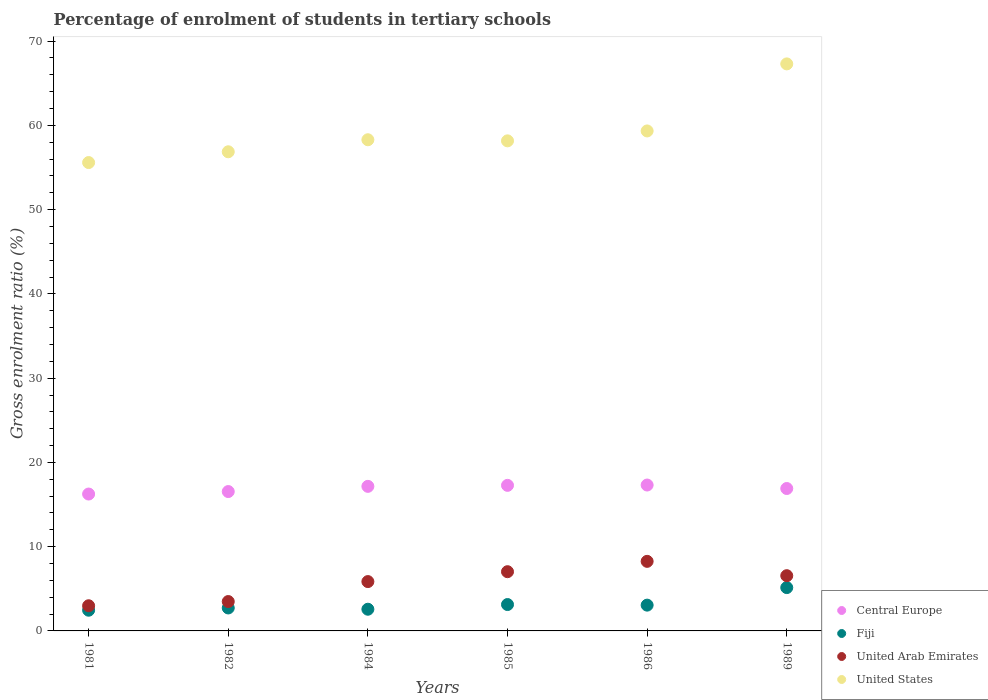How many different coloured dotlines are there?
Your answer should be compact. 4. Is the number of dotlines equal to the number of legend labels?
Make the answer very short. Yes. What is the percentage of students enrolled in tertiary schools in United Arab Emirates in 1981?
Provide a succinct answer. 2.99. Across all years, what is the maximum percentage of students enrolled in tertiary schools in Fiji?
Provide a short and direct response. 5.14. Across all years, what is the minimum percentage of students enrolled in tertiary schools in Fiji?
Provide a succinct answer. 2.46. What is the total percentage of students enrolled in tertiary schools in United States in the graph?
Make the answer very short. 355.55. What is the difference between the percentage of students enrolled in tertiary schools in Central Europe in 1981 and that in 1986?
Give a very brief answer. -1.07. What is the difference between the percentage of students enrolled in tertiary schools in United States in 1989 and the percentage of students enrolled in tertiary schools in Central Europe in 1981?
Give a very brief answer. 51.05. What is the average percentage of students enrolled in tertiary schools in Central Europe per year?
Your response must be concise. 16.91. In the year 1982, what is the difference between the percentage of students enrolled in tertiary schools in United States and percentage of students enrolled in tertiary schools in United Arab Emirates?
Offer a terse response. 53.38. What is the ratio of the percentage of students enrolled in tertiary schools in United Arab Emirates in 1981 to that in 1984?
Keep it short and to the point. 0.51. Is the percentage of students enrolled in tertiary schools in Central Europe in 1984 less than that in 1989?
Your response must be concise. No. What is the difference between the highest and the second highest percentage of students enrolled in tertiary schools in United States?
Ensure brevity in your answer.  7.96. What is the difference between the highest and the lowest percentage of students enrolled in tertiary schools in Fiji?
Give a very brief answer. 2.68. In how many years, is the percentage of students enrolled in tertiary schools in United States greater than the average percentage of students enrolled in tertiary schools in United States taken over all years?
Your answer should be compact. 2. Does the percentage of students enrolled in tertiary schools in United Arab Emirates monotonically increase over the years?
Ensure brevity in your answer.  No. Is the percentage of students enrolled in tertiary schools in Central Europe strictly greater than the percentage of students enrolled in tertiary schools in United Arab Emirates over the years?
Your answer should be very brief. Yes. How many dotlines are there?
Offer a very short reply. 4. How many years are there in the graph?
Make the answer very short. 6. Are the values on the major ticks of Y-axis written in scientific E-notation?
Make the answer very short. No. Does the graph contain grids?
Provide a succinct answer. No. Where does the legend appear in the graph?
Provide a succinct answer. Bottom right. What is the title of the graph?
Your answer should be compact. Percentage of enrolment of students in tertiary schools. What is the label or title of the Y-axis?
Your answer should be very brief. Gross enrolment ratio (%). What is the Gross enrolment ratio (%) of Central Europe in 1981?
Make the answer very short. 16.25. What is the Gross enrolment ratio (%) in Fiji in 1981?
Your answer should be very brief. 2.46. What is the Gross enrolment ratio (%) in United Arab Emirates in 1981?
Offer a terse response. 2.99. What is the Gross enrolment ratio (%) of United States in 1981?
Your answer should be compact. 55.59. What is the Gross enrolment ratio (%) of Central Europe in 1982?
Your answer should be very brief. 16.54. What is the Gross enrolment ratio (%) of Fiji in 1982?
Ensure brevity in your answer.  2.72. What is the Gross enrolment ratio (%) in United Arab Emirates in 1982?
Give a very brief answer. 3.49. What is the Gross enrolment ratio (%) in United States in 1982?
Ensure brevity in your answer.  56.87. What is the Gross enrolment ratio (%) in Central Europe in 1984?
Your response must be concise. 17.16. What is the Gross enrolment ratio (%) of Fiji in 1984?
Keep it short and to the point. 2.57. What is the Gross enrolment ratio (%) of United Arab Emirates in 1984?
Provide a succinct answer. 5.86. What is the Gross enrolment ratio (%) in United States in 1984?
Provide a succinct answer. 58.29. What is the Gross enrolment ratio (%) in Central Europe in 1985?
Provide a succinct answer. 17.28. What is the Gross enrolment ratio (%) in Fiji in 1985?
Your response must be concise. 3.13. What is the Gross enrolment ratio (%) of United Arab Emirates in 1985?
Your answer should be compact. 7.03. What is the Gross enrolment ratio (%) in United States in 1985?
Make the answer very short. 58.16. What is the Gross enrolment ratio (%) of Central Europe in 1986?
Your answer should be very brief. 17.32. What is the Gross enrolment ratio (%) of Fiji in 1986?
Your answer should be very brief. 3.06. What is the Gross enrolment ratio (%) in United Arab Emirates in 1986?
Your answer should be very brief. 8.26. What is the Gross enrolment ratio (%) in United States in 1986?
Your answer should be compact. 59.34. What is the Gross enrolment ratio (%) of Central Europe in 1989?
Offer a very short reply. 16.9. What is the Gross enrolment ratio (%) of Fiji in 1989?
Offer a terse response. 5.14. What is the Gross enrolment ratio (%) of United Arab Emirates in 1989?
Your response must be concise. 6.56. What is the Gross enrolment ratio (%) of United States in 1989?
Provide a short and direct response. 67.3. Across all years, what is the maximum Gross enrolment ratio (%) in Central Europe?
Provide a succinct answer. 17.32. Across all years, what is the maximum Gross enrolment ratio (%) of Fiji?
Your response must be concise. 5.14. Across all years, what is the maximum Gross enrolment ratio (%) in United Arab Emirates?
Give a very brief answer. 8.26. Across all years, what is the maximum Gross enrolment ratio (%) of United States?
Give a very brief answer. 67.3. Across all years, what is the minimum Gross enrolment ratio (%) of Central Europe?
Provide a succinct answer. 16.25. Across all years, what is the minimum Gross enrolment ratio (%) in Fiji?
Offer a terse response. 2.46. Across all years, what is the minimum Gross enrolment ratio (%) of United Arab Emirates?
Ensure brevity in your answer.  2.99. Across all years, what is the minimum Gross enrolment ratio (%) in United States?
Offer a terse response. 55.59. What is the total Gross enrolment ratio (%) in Central Europe in the graph?
Your response must be concise. 101.44. What is the total Gross enrolment ratio (%) in Fiji in the graph?
Offer a very short reply. 19.09. What is the total Gross enrolment ratio (%) of United Arab Emirates in the graph?
Your answer should be very brief. 34.17. What is the total Gross enrolment ratio (%) in United States in the graph?
Ensure brevity in your answer.  355.55. What is the difference between the Gross enrolment ratio (%) of Central Europe in 1981 and that in 1982?
Your answer should be compact. -0.3. What is the difference between the Gross enrolment ratio (%) of Fiji in 1981 and that in 1982?
Ensure brevity in your answer.  -0.27. What is the difference between the Gross enrolment ratio (%) of United Arab Emirates in 1981 and that in 1982?
Ensure brevity in your answer.  -0.5. What is the difference between the Gross enrolment ratio (%) of United States in 1981 and that in 1982?
Ensure brevity in your answer.  -1.28. What is the difference between the Gross enrolment ratio (%) of Central Europe in 1981 and that in 1984?
Provide a short and direct response. -0.91. What is the difference between the Gross enrolment ratio (%) in Fiji in 1981 and that in 1984?
Your answer should be compact. -0.12. What is the difference between the Gross enrolment ratio (%) in United Arab Emirates in 1981 and that in 1984?
Your response must be concise. -2.87. What is the difference between the Gross enrolment ratio (%) in United States in 1981 and that in 1984?
Offer a very short reply. -2.71. What is the difference between the Gross enrolment ratio (%) of Central Europe in 1981 and that in 1985?
Make the answer very short. -1.03. What is the difference between the Gross enrolment ratio (%) in Fiji in 1981 and that in 1985?
Your answer should be very brief. -0.67. What is the difference between the Gross enrolment ratio (%) in United Arab Emirates in 1981 and that in 1985?
Your answer should be very brief. -4.04. What is the difference between the Gross enrolment ratio (%) of United States in 1981 and that in 1985?
Give a very brief answer. -2.58. What is the difference between the Gross enrolment ratio (%) in Central Europe in 1981 and that in 1986?
Your answer should be very brief. -1.07. What is the difference between the Gross enrolment ratio (%) of Fiji in 1981 and that in 1986?
Provide a succinct answer. -0.6. What is the difference between the Gross enrolment ratio (%) of United Arab Emirates in 1981 and that in 1986?
Your answer should be compact. -5.27. What is the difference between the Gross enrolment ratio (%) in United States in 1981 and that in 1986?
Offer a very short reply. -3.75. What is the difference between the Gross enrolment ratio (%) in Central Europe in 1981 and that in 1989?
Offer a terse response. -0.66. What is the difference between the Gross enrolment ratio (%) of Fiji in 1981 and that in 1989?
Keep it short and to the point. -2.68. What is the difference between the Gross enrolment ratio (%) in United Arab Emirates in 1981 and that in 1989?
Make the answer very short. -3.57. What is the difference between the Gross enrolment ratio (%) of United States in 1981 and that in 1989?
Provide a succinct answer. -11.71. What is the difference between the Gross enrolment ratio (%) in Central Europe in 1982 and that in 1984?
Your answer should be very brief. -0.62. What is the difference between the Gross enrolment ratio (%) of Fiji in 1982 and that in 1984?
Give a very brief answer. 0.15. What is the difference between the Gross enrolment ratio (%) of United Arab Emirates in 1982 and that in 1984?
Provide a short and direct response. -2.37. What is the difference between the Gross enrolment ratio (%) of United States in 1982 and that in 1984?
Offer a very short reply. -1.43. What is the difference between the Gross enrolment ratio (%) of Central Europe in 1982 and that in 1985?
Provide a short and direct response. -0.74. What is the difference between the Gross enrolment ratio (%) in Fiji in 1982 and that in 1985?
Keep it short and to the point. -0.41. What is the difference between the Gross enrolment ratio (%) of United Arab Emirates in 1982 and that in 1985?
Make the answer very short. -3.54. What is the difference between the Gross enrolment ratio (%) of United States in 1982 and that in 1985?
Make the answer very short. -1.3. What is the difference between the Gross enrolment ratio (%) in Central Europe in 1982 and that in 1986?
Provide a short and direct response. -0.77. What is the difference between the Gross enrolment ratio (%) in Fiji in 1982 and that in 1986?
Give a very brief answer. -0.34. What is the difference between the Gross enrolment ratio (%) of United Arab Emirates in 1982 and that in 1986?
Provide a succinct answer. -4.77. What is the difference between the Gross enrolment ratio (%) of United States in 1982 and that in 1986?
Provide a succinct answer. -2.47. What is the difference between the Gross enrolment ratio (%) of Central Europe in 1982 and that in 1989?
Ensure brevity in your answer.  -0.36. What is the difference between the Gross enrolment ratio (%) of Fiji in 1982 and that in 1989?
Your answer should be very brief. -2.42. What is the difference between the Gross enrolment ratio (%) of United Arab Emirates in 1982 and that in 1989?
Your response must be concise. -3.07. What is the difference between the Gross enrolment ratio (%) of United States in 1982 and that in 1989?
Your response must be concise. -10.43. What is the difference between the Gross enrolment ratio (%) of Central Europe in 1984 and that in 1985?
Your answer should be compact. -0.12. What is the difference between the Gross enrolment ratio (%) of Fiji in 1984 and that in 1985?
Offer a terse response. -0.56. What is the difference between the Gross enrolment ratio (%) in United Arab Emirates in 1984 and that in 1985?
Provide a succinct answer. -1.17. What is the difference between the Gross enrolment ratio (%) in United States in 1984 and that in 1985?
Your answer should be very brief. 0.13. What is the difference between the Gross enrolment ratio (%) in Central Europe in 1984 and that in 1986?
Offer a very short reply. -0.16. What is the difference between the Gross enrolment ratio (%) in Fiji in 1984 and that in 1986?
Make the answer very short. -0.49. What is the difference between the Gross enrolment ratio (%) in United Arab Emirates in 1984 and that in 1986?
Offer a very short reply. -2.4. What is the difference between the Gross enrolment ratio (%) of United States in 1984 and that in 1986?
Give a very brief answer. -1.05. What is the difference between the Gross enrolment ratio (%) in Central Europe in 1984 and that in 1989?
Offer a very short reply. 0.26. What is the difference between the Gross enrolment ratio (%) in Fiji in 1984 and that in 1989?
Provide a short and direct response. -2.57. What is the difference between the Gross enrolment ratio (%) of United Arab Emirates in 1984 and that in 1989?
Keep it short and to the point. -0.7. What is the difference between the Gross enrolment ratio (%) in United States in 1984 and that in 1989?
Provide a succinct answer. -9. What is the difference between the Gross enrolment ratio (%) of Central Europe in 1985 and that in 1986?
Make the answer very short. -0.04. What is the difference between the Gross enrolment ratio (%) in Fiji in 1985 and that in 1986?
Your answer should be compact. 0.07. What is the difference between the Gross enrolment ratio (%) in United Arab Emirates in 1985 and that in 1986?
Provide a succinct answer. -1.23. What is the difference between the Gross enrolment ratio (%) of United States in 1985 and that in 1986?
Offer a terse response. -1.18. What is the difference between the Gross enrolment ratio (%) in Central Europe in 1985 and that in 1989?
Your answer should be compact. 0.38. What is the difference between the Gross enrolment ratio (%) of Fiji in 1985 and that in 1989?
Ensure brevity in your answer.  -2.01. What is the difference between the Gross enrolment ratio (%) of United Arab Emirates in 1985 and that in 1989?
Offer a very short reply. 0.47. What is the difference between the Gross enrolment ratio (%) in United States in 1985 and that in 1989?
Offer a terse response. -9.13. What is the difference between the Gross enrolment ratio (%) of Central Europe in 1986 and that in 1989?
Provide a short and direct response. 0.41. What is the difference between the Gross enrolment ratio (%) of Fiji in 1986 and that in 1989?
Make the answer very short. -2.08. What is the difference between the Gross enrolment ratio (%) in United Arab Emirates in 1986 and that in 1989?
Offer a very short reply. 1.7. What is the difference between the Gross enrolment ratio (%) of United States in 1986 and that in 1989?
Offer a very short reply. -7.96. What is the difference between the Gross enrolment ratio (%) in Central Europe in 1981 and the Gross enrolment ratio (%) in Fiji in 1982?
Ensure brevity in your answer.  13.52. What is the difference between the Gross enrolment ratio (%) in Central Europe in 1981 and the Gross enrolment ratio (%) in United Arab Emirates in 1982?
Provide a succinct answer. 12.76. What is the difference between the Gross enrolment ratio (%) of Central Europe in 1981 and the Gross enrolment ratio (%) of United States in 1982?
Offer a very short reply. -40.62. What is the difference between the Gross enrolment ratio (%) of Fiji in 1981 and the Gross enrolment ratio (%) of United Arab Emirates in 1982?
Give a very brief answer. -1.03. What is the difference between the Gross enrolment ratio (%) in Fiji in 1981 and the Gross enrolment ratio (%) in United States in 1982?
Offer a terse response. -54.41. What is the difference between the Gross enrolment ratio (%) in United Arab Emirates in 1981 and the Gross enrolment ratio (%) in United States in 1982?
Provide a succinct answer. -53.88. What is the difference between the Gross enrolment ratio (%) in Central Europe in 1981 and the Gross enrolment ratio (%) in Fiji in 1984?
Provide a short and direct response. 13.67. What is the difference between the Gross enrolment ratio (%) of Central Europe in 1981 and the Gross enrolment ratio (%) of United Arab Emirates in 1984?
Your answer should be very brief. 10.39. What is the difference between the Gross enrolment ratio (%) of Central Europe in 1981 and the Gross enrolment ratio (%) of United States in 1984?
Keep it short and to the point. -42.05. What is the difference between the Gross enrolment ratio (%) in Fiji in 1981 and the Gross enrolment ratio (%) in United Arab Emirates in 1984?
Provide a short and direct response. -3.4. What is the difference between the Gross enrolment ratio (%) in Fiji in 1981 and the Gross enrolment ratio (%) in United States in 1984?
Your response must be concise. -55.84. What is the difference between the Gross enrolment ratio (%) in United Arab Emirates in 1981 and the Gross enrolment ratio (%) in United States in 1984?
Offer a very short reply. -55.31. What is the difference between the Gross enrolment ratio (%) in Central Europe in 1981 and the Gross enrolment ratio (%) in Fiji in 1985?
Offer a very short reply. 13.11. What is the difference between the Gross enrolment ratio (%) of Central Europe in 1981 and the Gross enrolment ratio (%) of United Arab Emirates in 1985?
Offer a terse response. 9.22. What is the difference between the Gross enrolment ratio (%) of Central Europe in 1981 and the Gross enrolment ratio (%) of United States in 1985?
Your answer should be compact. -41.92. What is the difference between the Gross enrolment ratio (%) of Fiji in 1981 and the Gross enrolment ratio (%) of United Arab Emirates in 1985?
Keep it short and to the point. -4.57. What is the difference between the Gross enrolment ratio (%) of Fiji in 1981 and the Gross enrolment ratio (%) of United States in 1985?
Ensure brevity in your answer.  -55.71. What is the difference between the Gross enrolment ratio (%) of United Arab Emirates in 1981 and the Gross enrolment ratio (%) of United States in 1985?
Offer a terse response. -55.18. What is the difference between the Gross enrolment ratio (%) of Central Europe in 1981 and the Gross enrolment ratio (%) of Fiji in 1986?
Your answer should be very brief. 13.19. What is the difference between the Gross enrolment ratio (%) in Central Europe in 1981 and the Gross enrolment ratio (%) in United Arab Emirates in 1986?
Ensure brevity in your answer.  7.99. What is the difference between the Gross enrolment ratio (%) of Central Europe in 1981 and the Gross enrolment ratio (%) of United States in 1986?
Give a very brief answer. -43.09. What is the difference between the Gross enrolment ratio (%) in Fiji in 1981 and the Gross enrolment ratio (%) in United Arab Emirates in 1986?
Offer a very short reply. -5.8. What is the difference between the Gross enrolment ratio (%) of Fiji in 1981 and the Gross enrolment ratio (%) of United States in 1986?
Give a very brief answer. -56.88. What is the difference between the Gross enrolment ratio (%) in United Arab Emirates in 1981 and the Gross enrolment ratio (%) in United States in 1986?
Ensure brevity in your answer.  -56.35. What is the difference between the Gross enrolment ratio (%) in Central Europe in 1981 and the Gross enrolment ratio (%) in Fiji in 1989?
Ensure brevity in your answer.  11.1. What is the difference between the Gross enrolment ratio (%) of Central Europe in 1981 and the Gross enrolment ratio (%) of United Arab Emirates in 1989?
Make the answer very short. 9.69. What is the difference between the Gross enrolment ratio (%) of Central Europe in 1981 and the Gross enrolment ratio (%) of United States in 1989?
Provide a succinct answer. -51.05. What is the difference between the Gross enrolment ratio (%) in Fiji in 1981 and the Gross enrolment ratio (%) in United Arab Emirates in 1989?
Your answer should be compact. -4.1. What is the difference between the Gross enrolment ratio (%) in Fiji in 1981 and the Gross enrolment ratio (%) in United States in 1989?
Keep it short and to the point. -64.84. What is the difference between the Gross enrolment ratio (%) in United Arab Emirates in 1981 and the Gross enrolment ratio (%) in United States in 1989?
Ensure brevity in your answer.  -64.31. What is the difference between the Gross enrolment ratio (%) of Central Europe in 1982 and the Gross enrolment ratio (%) of Fiji in 1984?
Make the answer very short. 13.97. What is the difference between the Gross enrolment ratio (%) in Central Europe in 1982 and the Gross enrolment ratio (%) in United Arab Emirates in 1984?
Give a very brief answer. 10.69. What is the difference between the Gross enrolment ratio (%) in Central Europe in 1982 and the Gross enrolment ratio (%) in United States in 1984?
Make the answer very short. -41.75. What is the difference between the Gross enrolment ratio (%) in Fiji in 1982 and the Gross enrolment ratio (%) in United Arab Emirates in 1984?
Provide a succinct answer. -3.13. What is the difference between the Gross enrolment ratio (%) of Fiji in 1982 and the Gross enrolment ratio (%) of United States in 1984?
Your answer should be compact. -55.57. What is the difference between the Gross enrolment ratio (%) of United Arab Emirates in 1982 and the Gross enrolment ratio (%) of United States in 1984?
Provide a succinct answer. -54.81. What is the difference between the Gross enrolment ratio (%) in Central Europe in 1982 and the Gross enrolment ratio (%) in Fiji in 1985?
Your response must be concise. 13.41. What is the difference between the Gross enrolment ratio (%) of Central Europe in 1982 and the Gross enrolment ratio (%) of United Arab Emirates in 1985?
Keep it short and to the point. 9.51. What is the difference between the Gross enrolment ratio (%) of Central Europe in 1982 and the Gross enrolment ratio (%) of United States in 1985?
Give a very brief answer. -41.62. What is the difference between the Gross enrolment ratio (%) in Fiji in 1982 and the Gross enrolment ratio (%) in United Arab Emirates in 1985?
Ensure brevity in your answer.  -4.3. What is the difference between the Gross enrolment ratio (%) in Fiji in 1982 and the Gross enrolment ratio (%) in United States in 1985?
Keep it short and to the point. -55.44. What is the difference between the Gross enrolment ratio (%) in United Arab Emirates in 1982 and the Gross enrolment ratio (%) in United States in 1985?
Ensure brevity in your answer.  -54.68. What is the difference between the Gross enrolment ratio (%) of Central Europe in 1982 and the Gross enrolment ratio (%) of Fiji in 1986?
Offer a terse response. 13.48. What is the difference between the Gross enrolment ratio (%) in Central Europe in 1982 and the Gross enrolment ratio (%) in United Arab Emirates in 1986?
Provide a short and direct response. 8.28. What is the difference between the Gross enrolment ratio (%) in Central Europe in 1982 and the Gross enrolment ratio (%) in United States in 1986?
Provide a short and direct response. -42.8. What is the difference between the Gross enrolment ratio (%) in Fiji in 1982 and the Gross enrolment ratio (%) in United Arab Emirates in 1986?
Make the answer very short. -5.53. What is the difference between the Gross enrolment ratio (%) of Fiji in 1982 and the Gross enrolment ratio (%) of United States in 1986?
Give a very brief answer. -56.62. What is the difference between the Gross enrolment ratio (%) of United Arab Emirates in 1982 and the Gross enrolment ratio (%) of United States in 1986?
Provide a succinct answer. -55.85. What is the difference between the Gross enrolment ratio (%) of Central Europe in 1982 and the Gross enrolment ratio (%) of Fiji in 1989?
Provide a succinct answer. 11.4. What is the difference between the Gross enrolment ratio (%) of Central Europe in 1982 and the Gross enrolment ratio (%) of United Arab Emirates in 1989?
Provide a short and direct response. 9.99. What is the difference between the Gross enrolment ratio (%) in Central Europe in 1982 and the Gross enrolment ratio (%) in United States in 1989?
Give a very brief answer. -50.76. What is the difference between the Gross enrolment ratio (%) in Fiji in 1982 and the Gross enrolment ratio (%) in United Arab Emirates in 1989?
Ensure brevity in your answer.  -3.83. What is the difference between the Gross enrolment ratio (%) of Fiji in 1982 and the Gross enrolment ratio (%) of United States in 1989?
Ensure brevity in your answer.  -64.57. What is the difference between the Gross enrolment ratio (%) in United Arab Emirates in 1982 and the Gross enrolment ratio (%) in United States in 1989?
Your answer should be very brief. -63.81. What is the difference between the Gross enrolment ratio (%) of Central Europe in 1984 and the Gross enrolment ratio (%) of Fiji in 1985?
Your response must be concise. 14.03. What is the difference between the Gross enrolment ratio (%) of Central Europe in 1984 and the Gross enrolment ratio (%) of United Arab Emirates in 1985?
Your answer should be very brief. 10.13. What is the difference between the Gross enrolment ratio (%) in Central Europe in 1984 and the Gross enrolment ratio (%) in United States in 1985?
Offer a very short reply. -41.01. What is the difference between the Gross enrolment ratio (%) of Fiji in 1984 and the Gross enrolment ratio (%) of United Arab Emirates in 1985?
Offer a terse response. -4.46. What is the difference between the Gross enrolment ratio (%) of Fiji in 1984 and the Gross enrolment ratio (%) of United States in 1985?
Offer a terse response. -55.59. What is the difference between the Gross enrolment ratio (%) of United Arab Emirates in 1984 and the Gross enrolment ratio (%) of United States in 1985?
Your response must be concise. -52.31. What is the difference between the Gross enrolment ratio (%) in Central Europe in 1984 and the Gross enrolment ratio (%) in Fiji in 1986?
Your answer should be compact. 14.1. What is the difference between the Gross enrolment ratio (%) of Central Europe in 1984 and the Gross enrolment ratio (%) of United Arab Emirates in 1986?
Provide a succinct answer. 8.9. What is the difference between the Gross enrolment ratio (%) in Central Europe in 1984 and the Gross enrolment ratio (%) in United States in 1986?
Provide a succinct answer. -42.18. What is the difference between the Gross enrolment ratio (%) in Fiji in 1984 and the Gross enrolment ratio (%) in United Arab Emirates in 1986?
Provide a short and direct response. -5.68. What is the difference between the Gross enrolment ratio (%) in Fiji in 1984 and the Gross enrolment ratio (%) in United States in 1986?
Your answer should be very brief. -56.77. What is the difference between the Gross enrolment ratio (%) of United Arab Emirates in 1984 and the Gross enrolment ratio (%) of United States in 1986?
Offer a terse response. -53.48. What is the difference between the Gross enrolment ratio (%) in Central Europe in 1984 and the Gross enrolment ratio (%) in Fiji in 1989?
Offer a terse response. 12.02. What is the difference between the Gross enrolment ratio (%) of Central Europe in 1984 and the Gross enrolment ratio (%) of United Arab Emirates in 1989?
Give a very brief answer. 10.6. What is the difference between the Gross enrolment ratio (%) of Central Europe in 1984 and the Gross enrolment ratio (%) of United States in 1989?
Keep it short and to the point. -50.14. What is the difference between the Gross enrolment ratio (%) in Fiji in 1984 and the Gross enrolment ratio (%) in United Arab Emirates in 1989?
Ensure brevity in your answer.  -3.98. What is the difference between the Gross enrolment ratio (%) of Fiji in 1984 and the Gross enrolment ratio (%) of United States in 1989?
Offer a very short reply. -64.72. What is the difference between the Gross enrolment ratio (%) of United Arab Emirates in 1984 and the Gross enrolment ratio (%) of United States in 1989?
Make the answer very short. -61.44. What is the difference between the Gross enrolment ratio (%) in Central Europe in 1985 and the Gross enrolment ratio (%) in Fiji in 1986?
Make the answer very short. 14.22. What is the difference between the Gross enrolment ratio (%) of Central Europe in 1985 and the Gross enrolment ratio (%) of United Arab Emirates in 1986?
Offer a terse response. 9.02. What is the difference between the Gross enrolment ratio (%) in Central Europe in 1985 and the Gross enrolment ratio (%) in United States in 1986?
Provide a succinct answer. -42.06. What is the difference between the Gross enrolment ratio (%) in Fiji in 1985 and the Gross enrolment ratio (%) in United Arab Emirates in 1986?
Make the answer very short. -5.13. What is the difference between the Gross enrolment ratio (%) of Fiji in 1985 and the Gross enrolment ratio (%) of United States in 1986?
Offer a very short reply. -56.21. What is the difference between the Gross enrolment ratio (%) of United Arab Emirates in 1985 and the Gross enrolment ratio (%) of United States in 1986?
Your response must be concise. -52.31. What is the difference between the Gross enrolment ratio (%) in Central Europe in 1985 and the Gross enrolment ratio (%) in Fiji in 1989?
Provide a short and direct response. 12.13. What is the difference between the Gross enrolment ratio (%) of Central Europe in 1985 and the Gross enrolment ratio (%) of United Arab Emirates in 1989?
Your response must be concise. 10.72. What is the difference between the Gross enrolment ratio (%) in Central Europe in 1985 and the Gross enrolment ratio (%) in United States in 1989?
Make the answer very short. -50.02. What is the difference between the Gross enrolment ratio (%) in Fiji in 1985 and the Gross enrolment ratio (%) in United Arab Emirates in 1989?
Your answer should be compact. -3.42. What is the difference between the Gross enrolment ratio (%) of Fiji in 1985 and the Gross enrolment ratio (%) of United States in 1989?
Offer a very short reply. -64.17. What is the difference between the Gross enrolment ratio (%) in United Arab Emirates in 1985 and the Gross enrolment ratio (%) in United States in 1989?
Ensure brevity in your answer.  -60.27. What is the difference between the Gross enrolment ratio (%) in Central Europe in 1986 and the Gross enrolment ratio (%) in Fiji in 1989?
Your answer should be compact. 12.17. What is the difference between the Gross enrolment ratio (%) in Central Europe in 1986 and the Gross enrolment ratio (%) in United Arab Emirates in 1989?
Your answer should be very brief. 10.76. What is the difference between the Gross enrolment ratio (%) in Central Europe in 1986 and the Gross enrolment ratio (%) in United States in 1989?
Offer a terse response. -49.98. What is the difference between the Gross enrolment ratio (%) in Fiji in 1986 and the Gross enrolment ratio (%) in United Arab Emirates in 1989?
Make the answer very short. -3.49. What is the difference between the Gross enrolment ratio (%) in Fiji in 1986 and the Gross enrolment ratio (%) in United States in 1989?
Provide a succinct answer. -64.24. What is the difference between the Gross enrolment ratio (%) in United Arab Emirates in 1986 and the Gross enrolment ratio (%) in United States in 1989?
Your response must be concise. -59.04. What is the average Gross enrolment ratio (%) in Central Europe per year?
Offer a very short reply. 16.91. What is the average Gross enrolment ratio (%) of Fiji per year?
Provide a short and direct response. 3.18. What is the average Gross enrolment ratio (%) in United Arab Emirates per year?
Make the answer very short. 5.7. What is the average Gross enrolment ratio (%) in United States per year?
Offer a very short reply. 59.26. In the year 1981, what is the difference between the Gross enrolment ratio (%) of Central Europe and Gross enrolment ratio (%) of Fiji?
Keep it short and to the point. 13.79. In the year 1981, what is the difference between the Gross enrolment ratio (%) in Central Europe and Gross enrolment ratio (%) in United Arab Emirates?
Offer a very short reply. 13.26. In the year 1981, what is the difference between the Gross enrolment ratio (%) of Central Europe and Gross enrolment ratio (%) of United States?
Offer a terse response. -39.34. In the year 1981, what is the difference between the Gross enrolment ratio (%) in Fiji and Gross enrolment ratio (%) in United Arab Emirates?
Give a very brief answer. -0.53. In the year 1981, what is the difference between the Gross enrolment ratio (%) of Fiji and Gross enrolment ratio (%) of United States?
Your answer should be compact. -53.13. In the year 1981, what is the difference between the Gross enrolment ratio (%) of United Arab Emirates and Gross enrolment ratio (%) of United States?
Provide a succinct answer. -52.6. In the year 1982, what is the difference between the Gross enrolment ratio (%) in Central Europe and Gross enrolment ratio (%) in Fiji?
Offer a terse response. 13.82. In the year 1982, what is the difference between the Gross enrolment ratio (%) of Central Europe and Gross enrolment ratio (%) of United Arab Emirates?
Make the answer very short. 13.06. In the year 1982, what is the difference between the Gross enrolment ratio (%) of Central Europe and Gross enrolment ratio (%) of United States?
Your response must be concise. -40.33. In the year 1982, what is the difference between the Gross enrolment ratio (%) in Fiji and Gross enrolment ratio (%) in United Arab Emirates?
Keep it short and to the point. -0.76. In the year 1982, what is the difference between the Gross enrolment ratio (%) of Fiji and Gross enrolment ratio (%) of United States?
Provide a short and direct response. -54.14. In the year 1982, what is the difference between the Gross enrolment ratio (%) of United Arab Emirates and Gross enrolment ratio (%) of United States?
Offer a terse response. -53.38. In the year 1984, what is the difference between the Gross enrolment ratio (%) in Central Europe and Gross enrolment ratio (%) in Fiji?
Provide a short and direct response. 14.58. In the year 1984, what is the difference between the Gross enrolment ratio (%) of Central Europe and Gross enrolment ratio (%) of United Arab Emirates?
Provide a short and direct response. 11.3. In the year 1984, what is the difference between the Gross enrolment ratio (%) of Central Europe and Gross enrolment ratio (%) of United States?
Your response must be concise. -41.14. In the year 1984, what is the difference between the Gross enrolment ratio (%) in Fiji and Gross enrolment ratio (%) in United Arab Emirates?
Offer a very short reply. -3.28. In the year 1984, what is the difference between the Gross enrolment ratio (%) of Fiji and Gross enrolment ratio (%) of United States?
Make the answer very short. -55.72. In the year 1984, what is the difference between the Gross enrolment ratio (%) in United Arab Emirates and Gross enrolment ratio (%) in United States?
Give a very brief answer. -52.44. In the year 1985, what is the difference between the Gross enrolment ratio (%) of Central Europe and Gross enrolment ratio (%) of Fiji?
Ensure brevity in your answer.  14.15. In the year 1985, what is the difference between the Gross enrolment ratio (%) in Central Europe and Gross enrolment ratio (%) in United Arab Emirates?
Ensure brevity in your answer.  10.25. In the year 1985, what is the difference between the Gross enrolment ratio (%) in Central Europe and Gross enrolment ratio (%) in United States?
Provide a short and direct response. -40.89. In the year 1985, what is the difference between the Gross enrolment ratio (%) in Fiji and Gross enrolment ratio (%) in United Arab Emirates?
Your answer should be compact. -3.9. In the year 1985, what is the difference between the Gross enrolment ratio (%) of Fiji and Gross enrolment ratio (%) of United States?
Make the answer very short. -55.03. In the year 1985, what is the difference between the Gross enrolment ratio (%) of United Arab Emirates and Gross enrolment ratio (%) of United States?
Your response must be concise. -51.14. In the year 1986, what is the difference between the Gross enrolment ratio (%) in Central Europe and Gross enrolment ratio (%) in Fiji?
Ensure brevity in your answer.  14.25. In the year 1986, what is the difference between the Gross enrolment ratio (%) of Central Europe and Gross enrolment ratio (%) of United Arab Emirates?
Your answer should be very brief. 9.06. In the year 1986, what is the difference between the Gross enrolment ratio (%) in Central Europe and Gross enrolment ratio (%) in United States?
Ensure brevity in your answer.  -42.02. In the year 1986, what is the difference between the Gross enrolment ratio (%) of Fiji and Gross enrolment ratio (%) of United Arab Emirates?
Offer a very short reply. -5.2. In the year 1986, what is the difference between the Gross enrolment ratio (%) of Fiji and Gross enrolment ratio (%) of United States?
Your answer should be very brief. -56.28. In the year 1986, what is the difference between the Gross enrolment ratio (%) in United Arab Emirates and Gross enrolment ratio (%) in United States?
Your response must be concise. -51.08. In the year 1989, what is the difference between the Gross enrolment ratio (%) in Central Europe and Gross enrolment ratio (%) in Fiji?
Provide a short and direct response. 11.76. In the year 1989, what is the difference between the Gross enrolment ratio (%) of Central Europe and Gross enrolment ratio (%) of United Arab Emirates?
Offer a terse response. 10.35. In the year 1989, what is the difference between the Gross enrolment ratio (%) in Central Europe and Gross enrolment ratio (%) in United States?
Offer a terse response. -50.4. In the year 1989, what is the difference between the Gross enrolment ratio (%) in Fiji and Gross enrolment ratio (%) in United Arab Emirates?
Ensure brevity in your answer.  -1.41. In the year 1989, what is the difference between the Gross enrolment ratio (%) in Fiji and Gross enrolment ratio (%) in United States?
Your response must be concise. -62.16. In the year 1989, what is the difference between the Gross enrolment ratio (%) of United Arab Emirates and Gross enrolment ratio (%) of United States?
Keep it short and to the point. -60.74. What is the ratio of the Gross enrolment ratio (%) of Central Europe in 1981 to that in 1982?
Give a very brief answer. 0.98. What is the ratio of the Gross enrolment ratio (%) of Fiji in 1981 to that in 1982?
Your answer should be compact. 0.9. What is the ratio of the Gross enrolment ratio (%) of United Arab Emirates in 1981 to that in 1982?
Provide a succinct answer. 0.86. What is the ratio of the Gross enrolment ratio (%) of United States in 1981 to that in 1982?
Provide a short and direct response. 0.98. What is the ratio of the Gross enrolment ratio (%) of Central Europe in 1981 to that in 1984?
Your answer should be compact. 0.95. What is the ratio of the Gross enrolment ratio (%) in Fiji in 1981 to that in 1984?
Provide a short and direct response. 0.96. What is the ratio of the Gross enrolment ratio (%) of United Arab Emirates in 1981 to that in 1984?
Provide a short and direct response. 0.51. What is the ratio of the Gross enrolment ratio (%) in United States in 1981 to that in 1984?
Provide a short and direct response. 0.95. What is the ratio of the Gross enrolment ratio (%) of Central Europe in 1981 to that in 1985?
Your answer should be compact. 0.94. What is the ratio of the Gross enrolment ratio (%) in Fiji in 1981 to that in 1985?
Provide a short and direct response. 0.79. What is the ratio of the Gross enrolment ratio (%) in United Arab Emirates in 1981 to that in 1985?
Provide a succinct answer. 0.42. What is the ratio of the Gross enrolment ratio (%) of United States in 1981 to that in 1985?
Your answer should be compact. 0.96. What is the ratio of the Gross enrolment ratio (%) in Central Europe in 1981 to that in 1986?
Provide a short and direct response. 0.94. What is the ratio of the Gross enrolment ratio (%) of Fiji in 1981 to that in 1986?
Give a very brief answer. 0.8. What is the ratio of the Gross enrolment ratio (%) of United Arab Emirates in 1981 to that in 1986?
Your response must be concise. 0.36. What is the ratio of the Gross enrolment ratio (%) in United States in 1981 to that in 1986?
Offer a terse response. 0.94. What is the ratio of the Gross enrolment ratio (%) of Central Europe in 1981 to that in 1989?
Offer a very short reply. 0.96. What is the ratio of the Gross enrolment ratio (%) of Fiji in 1981 to that in 1989?
Your answer should be compact. 0.48. What is the ratio of the Gross enrolment ratio (%) of United Arab Emirates in 1981 to that in 1989?
Make the answer very short. 0.46. What is the ratio of the Gross enrolment ratio (%) in United States in 1981 to that in 1989?
Offer a terse response. 0.83. What is the ratio of the Gross enrolment ratio (%) of Central Europe in 1982 to that in 1984?
Your answer should be compact. 0.96. What is the ratio of the Gross enrolment ratio (%) in Fiji in 1982 to that in 1984?
Offer a terse response. 1.06. What is the ratio of the Gross enrolment ratio (%) in United Arab Emirates in 1982 to that in 1984?
Your answer should be very brief. 0.6. What is the ratio of the Gross enrolment ratio (%) in United States in 1982 to that in 1984?
Keep it short and to the point. 0.98. What is the ratio of the Gross enrolment ratio (%) in Central Europe in 1982 to that in 1985?
Provide a short and direct response. 0.96. What is the ratio of the Gross enrolment ratio (%) in Fiji in 1982 to that in 1985?
Provide a short and direct response. 0.87. What is the ratio of the Gross enrolment ratio (%) in United Arab Emirates in 1982 to that in 1985?
Give a very brief answer. 0.5. What is the ratio of the Gross enrolment ratio (%) of United States in 1982 to that in 1985?
Keep it short and to the point. 0.98. What is the ratio of the Gross enrolment ratio (%) in Central Europe in 1982 to that in 1986?
Your answer should be very brief. 0.96. What is the ratio of the Gross enrolment ratio (%) in Fiji in 1982 to that in 1986?
Provide a short and direct response. 0.89. What is the ratio of the Gross enrolment ratio (%) in United Arab Emirates in 1982 to that in 1986?
Provide a short and direct response. 0.42. What is the ratio of the Gross enrolment ratio (%) of United States in 1982 to that in 1986?
Provide a short and direct response. 0.96. What is the ratio of the Gross enrolment ratio (%) of Central Europe in 1982 to that in 1989?
Your answer should be compact. 0.98. What is the ratio of the Gross enrolment ratio (%) of Fiji in 1982 to that in 1989?
Offer a very short reply. 0.53. What is the ratio of the Gross enrolment ratio (%) in United Arab Emirates in 1982 to that in 1989?
Offer a terse response. 0.53. What is the ratio of the Gross enrolment ratio (%) of United States in 1982 to that in 1989?
Offer a terse response. 0.84. What is the ratio of the Gross enrolment ratio (%) of Central Europe in 1984 to that in 1985?
Your response must be concise. 0.99. What is the ratio of the Gross enrolment ratio (%) in Fiji in 1984 to that in 1985?
Your response must be concise. 0.82. What is the ratio of the Gross enrolment ratio (%) of United Arab Emirates in 1984 to that in 1985?
Your answer should be very brief. 0.83. What is the ratio of the Gross enrolment ratio (%) in Central Europe in 1984 to that in 1986?
Give a very brief answer. 0.99. What is the ratio of the Gross enrolment ratio (%) in Fiji in 1984 to that in 1986?
Your response must be concise. 0.84. What is the ratio of the Gross enrolment ratio (%) of United Arab Emirates in 1984 to that in 1986?
Your answer should be compact. 0.71. What is the ratio of the Gross enrolment ratio (%) of United States in 1984 to that in 1986?
Provide a succinct answer. 0.98. What is the ratio of the Gross enrolment ratio (%) in Central Europe in 1984 to that in 1989?
Offer a terse response. 1.02. What is the ratio of the Gross enrolment ratio (%) of Fiji in 1984 to that in 1989?
Provide a succinct answer. 0.5. What is the ratio of the Gross enrolment ratio (%) of United Arab Emirates in 1984 to that in 1989?
Your response must be concise. 0.89. What is the ratio of the Gross enrolment ratio (%) in United States in 1984 to that in 1989?
Your response must be concise. 0.87. What is the ratio of the Gross enrolment ratio (%) of Central Europe in 1985 to that in 1986?
Offer a very short reply. 1. What is the ratio of the Gross enrolment ratio (%) in Fiji in 1985 to that in 1986?
Offer a terse response. 1.02. What is the ratio of the Gross enrolment ratio (%) in United Arab Emirates in 1985 to that in 1986?
Provide a succinct answer. 0.85. What is the ratio of the Gross enrolment ratio (%) of United States in 1985 to that in 1986?
Provide a succinct answer. 0.98. What is the ratio of the Gross enrolment ratio (%) of Central Europe in 1985 to that in 1989?
Your response must be concise. 1.02. What is the ratio of the Gross enrolment ratio (%) in Fiji in 1985 to that in 1989?
Your answer should be compact. 0.61. What is the ratio of the Gross enrolment ratio (%) in United Arab Emirates in 1985 to that in 1989?
Offer a very short reply. 1.07. What is the ratio of the Gross enrolment ratio (%) of United States in 1985 to that in 1989?
Ensure brevity in your answer.  0.86. What is the ratio of the Gross enrolment ratio (%) of Central Europe in 1986 to that in 1989?
Offer a terse response. 1.02. What is the ratio of the Gross enrolment ratio (%) in Fiji in 1986 to that in 1989?
Give a very brief answer. 0.6. What is the ratio of the Gross enrolment ratio (%) of United Arab Emirates in 1986 to that in 1989?
Your answer should be compact. 1.26. What is the ratio of the Gross enrolment ratio (%) in United States in 1986 to that in 1989?
Give a very brief answer. 0.88. What is the difference between the highest and the second highest Gross enrolment ratio (%) in Central Europe?
Provide a short and direct response. 0.04. What is the difference between the highest and the second highest Gross enrolment ratio (%) in Fiji?
Ensure brevity in your answer.  2.01. What is the difference between the highest and the second highest Gross enrolment ratio (%) in United Arab Emirates?
Ensure brevity in your answer.  1.23. What is the difference between the highest and the second highest Gross enrolment ratio (%) in United States?
Ensure brevity in your answer.  7.96. What is the difference between the highest and the lowest Gross enrolment ratio (%) of Central Europe?
Offer a terse response. 1.07. What is the difference between the highest and the lowest Gross enrolment ratio (%) of Fiji?
Offer a terse response. 2.68. What is the difference between the highest and the lowest Gross enrolment ratio (%) of United Arab Emirates?
Provide a short and direct response. 5.27. What is the difference between the highest and the lowest Gross enrolment ratio (%) in United States?
Offer a terse response. 11.71. 